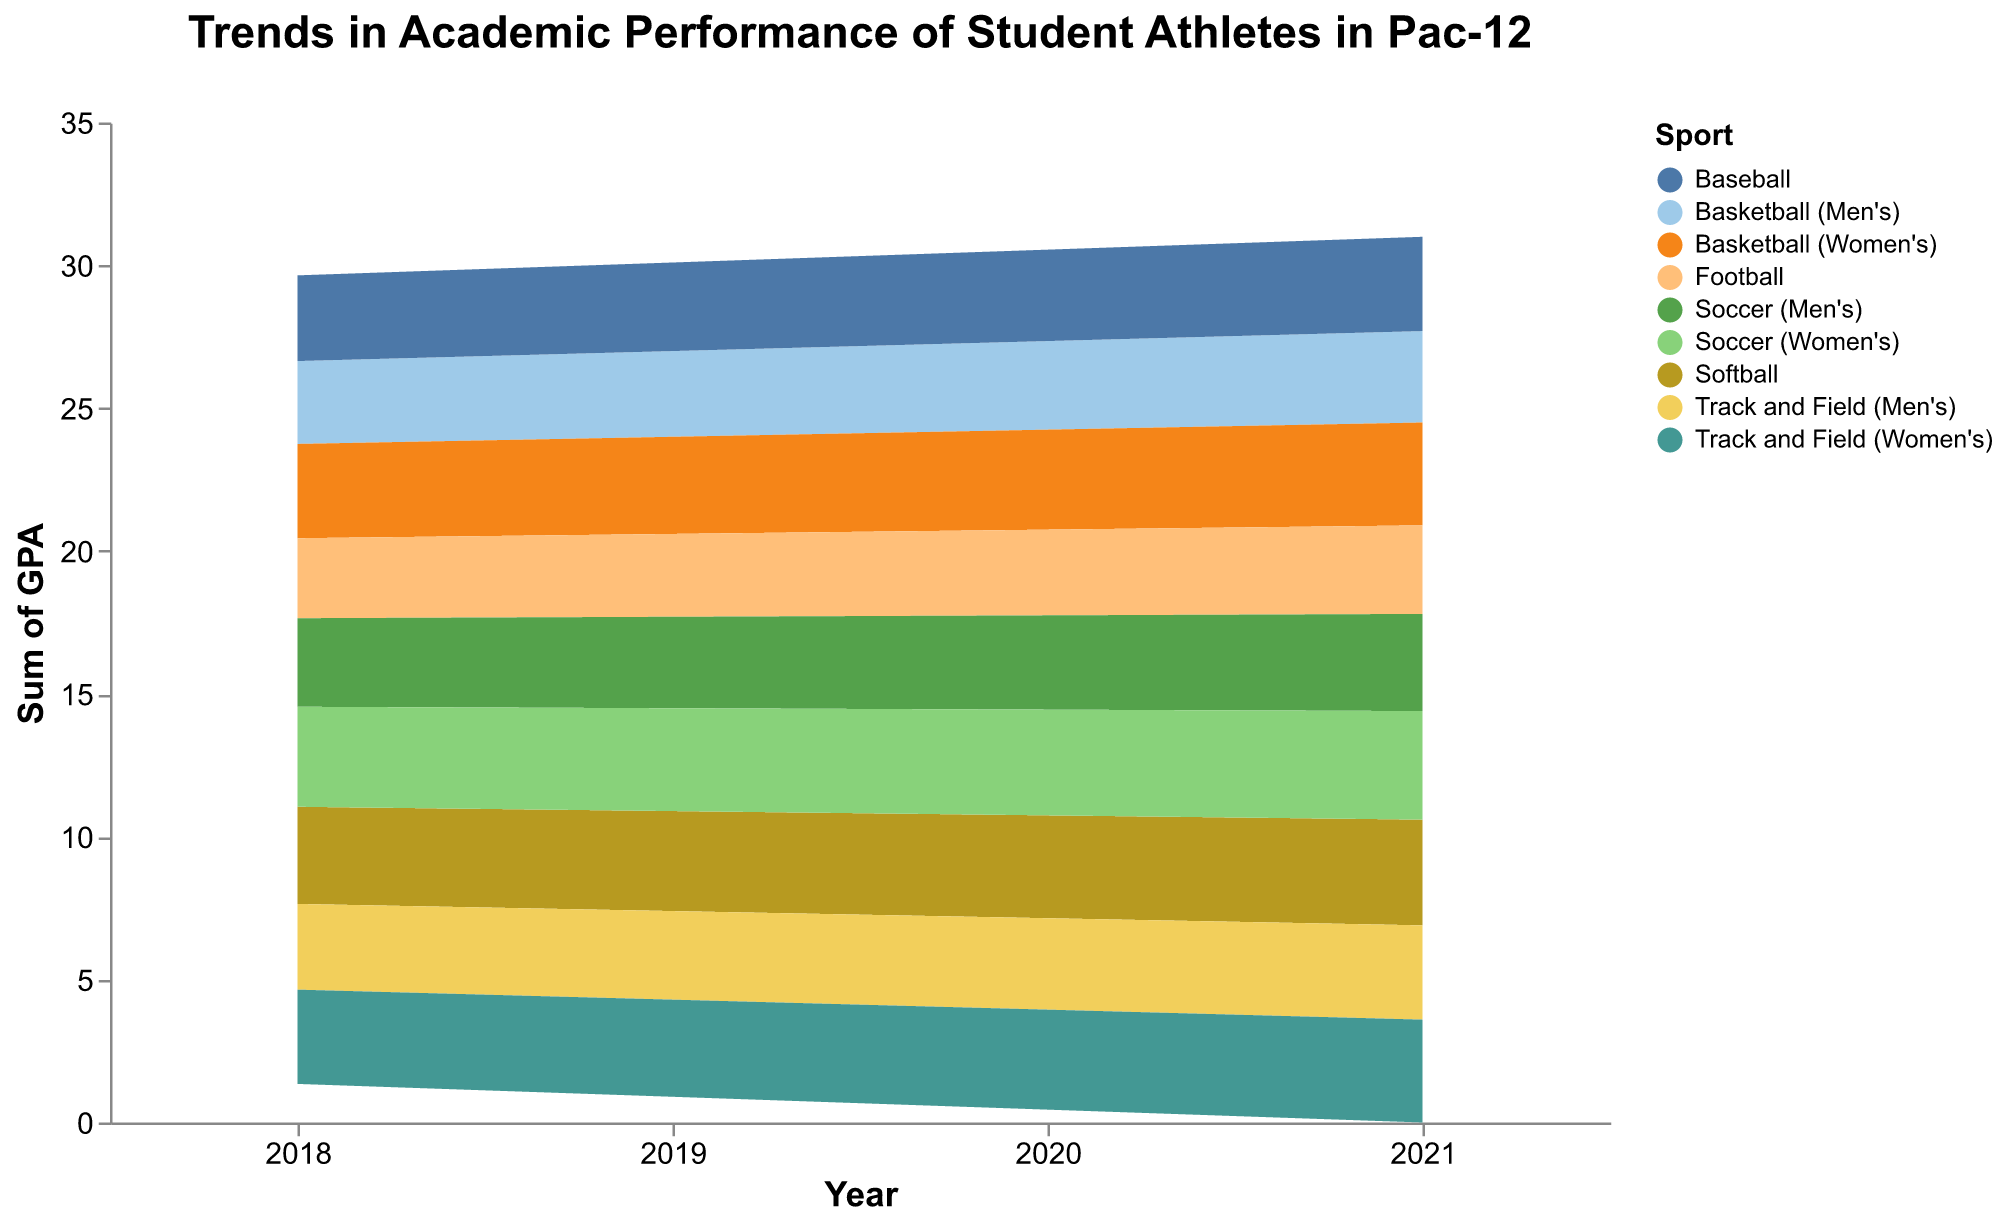What is the overall trend in GPA for men's basketball from 2018 to 2021? The GPAs for men's basketball increase from 2.9 in 2018 to 3.2 in 2021.
Answer: Increasing Which sport has the highest GPA in 2021? The highest GPA in 2021 is 3.8 for women's soccer.
Answer: Women's soccer What is the difference in GPA between men's and women's basketball in the year 2020? In 2020, the GPA for men's basketball is 3.1 and for women's basketball is 3.5. The difference is 3.5 - 3.1 = 0.4.
Answer: 0.4 How does the GPA trend for football compare to that of baseball from 2018 to 2021? Both football and baseball show an increasing trend from 2018 to 2021. Football's GPA increases from 2.8 to 3.1, while baseball's GPA increases from 3.0 to 3.3.
Answer: Both increase Which sport shows the greatest improvement in GPA from 2018 to 2021? Women's soccer shows the greatest improvement, with the GPA increasing from 3.5 to 3.8, an increase of 0.3.
Answer: Women's soccer What is the average GPA for men's sports in 2019? The GPAs for men's sports in 2019 are 3.0 (basketball), 2.9 (football), 3.1 (baseball), 3.2 (soccer), and 3.1 (track and field). The average is (3.0 + 2.9 + 3.1 + 3.2 + 3.1) / 5 = 3.06.
Answer: 3.06 How do GPA trends for men's and women's soccer differ from 2018 to 2021? Both men's and women's soccer show an increasing trend. However, women's soccer starts at a higher GPA of 3.5 in 2018 and increases to 3.8 in 2021, while men's soccer increases from 3.1 to 3.4.
Answer: Women's soccer starts higher and increases more Which sport maintains the most consistent year-to-year GPA improvement from 2018 to 2021? Women's soccer shows consistent year-to-year improvement with increases of 0.1 each year.
Answer: Women's soccer What is the combined GPA of all sports in 2020? Summing the GPAs for all sports in 2020: 3.1 (men's basketball) + 3.5 (women's basketball) + 3.0 (football) + 3.2 (baseball) + 3.6 (softball) + 3.3 (men's soccer) + 3.7 (women's soccer) + 3.2 (men's track and field) + 3.5 (women's track and field) = 29.1.
Answer: 29.1 